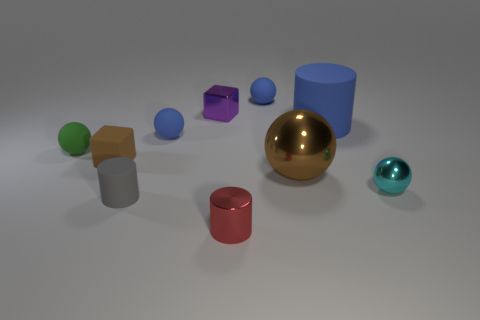Subtract 2 spheres. How many spheres are left? 3 Subtract all cyan spheres. How many spheres are left? 4 Subtract all green spheres. How many spheres are left? 4 Subtract all red spheres. Subtract all brown cubes. How many spheres are left? 5 Subtract all cylinders. How many objects are left? 7 Subtract all tiny yellow cubes. Subtract all blocks. How many objects are left? 8 Add 3 large brown shiny things. How many large brown shiny things are left? 4 Add 1 matte spheres. How many matte spheres exist? 4 Subtract 0 yellow cylinders. How many objects are left? 10 